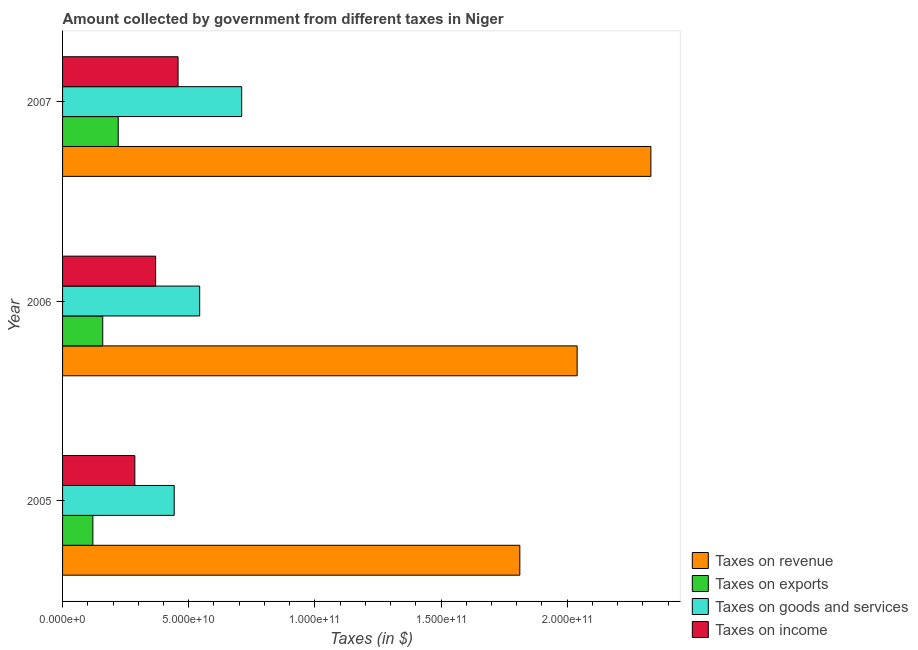How many different coloured bars are there?
Your answer should be very brief. 4. How many bars are there on the 3rd tick from the top?
Give a very brief answer. 4. What is the label of the 2nd group of bars from the top?
Provide a succinct answer. 2006. In how many cases, is the number of bars for a given year not equal to the number of legend labels?
Offer a very short reply. 0. What is the amount collected as tax on exports in 2007?
Your answer should be very brief. 2.21e+1. Across all years, what is the maximum amount collected as tax on income?
Provide a short and direct response. 4.58e+1. Across all years, what is the minimum amount collected as tax on income?
Provide a succinct answer. 2.86e+1. In which year was the amount collected as tax on income maximum?
Offer a terse response. 2007. What is the total amount collected as tax on revenue in the graph?
Keep it short and to the point. 6.18e+11. What is the difference between the amount collected as tax on revenue in 2005 and that in 2007?
Your answer should be compact. -5.19e+1. What is the difference between the amount collected as tax on exports in 2006 and the amount collected as tax on income in 2007?
Offer a very short reply. -2.99e+1. What is the average amount collected as tax on income per year?
Your answer should be very brief. 3.71e+1. In the year 2005, what is the difference between the amount collected as tax on goods and amount collected as tax on exports?
Offer a very short reply. 3.22e+1. What is the ratio of the amount collected as tax on exports in 2005 to that in 2006?
Offer a very short reply. 0.75. What is the difference between the highest and the second highest amount collected as tax on revenue?
Offer a terse response. 2.92e+1. What is the difference between the highest and the lowest amount collected as tax on exports?
Provide a short and direct response. 1.01e+1. In how many years, is the amount collected as tax on income greater than the average amount collected as tax on income taken over all years?
Your answer should be compact. 1. Is the sum of the amount collected as tax on revenue in 2005 and 2007 greater than the maximum amount collected as tax on income across all years?
Offer a very short reply. Yes. What does the 3rd bar from the top in 2006 represents?
Ensure brevity in your answer.  Taxes on exports. What does the 1st bar from the bottom in 2007 represents?
Ensure brevity in your answer.  Taxes on revenue. Is it the case that in every year, the sum of the amount collected as tax on revenue and amount collected as tax on exports is greater than the amount collected as tax on goods?
Offer a terse response. Yes. How many bars are there?
Your answer should be very brief. 12. Are all the bars in the graph horizontal?
Provide a succinct answer. Yes. How many years are there in the graph?
Provide a short and direct response. 3. What is the difference between two consecutive major ticks on the X-axis?
Provide a succinct answer. 5.00e+1. Are the values on the major ticks of X-axis written in scientific E-notation?
Offer a very short reply. Yes. Where does the legend appear in the graph?
Give a very brief answer. Bottom right. What is the title of the graph?
Your response must be concise. Amount collected by government from different taxes in Niger. Does "Rule based governance" appear as one of the legend labels in the graph?
Provide a short and direct response. No. What is the label or title of the X-axis?
Your response must be concise. Taxes (in $). What is the label or title of the Y-axis?
Your answer should be compact. Year. What is the Taxes (in $) in Taxes on revenue in 2005?
Give a very brief answer. 1.81e+11. What is the Taxes (in $) in Taxes on exports in 2005?
Provide a succinct answer. 1.20e+1. What is the Taxes (in $) of Taxes on goods and services in 2005?
Your answer should be very brief. 4.43e+1. What is the Taxes (in $) of Taxes on income in 2005?
Keep it short and to the point. 2.86e+1. What is the Taxes (in $) in Taxes on revenue in 2006?
Provide a short and direct response. 2.04e+11. What is the Taxes (in $) in Taxes on exports in 2006?
Your answer should be compact. 1.59e+1. What is the Taxes (in $) in Taxes on goods and services in 2006?
Your answer should be compact. 5.43e+1. What is the Taxes (in $) in Taxes on income in 2006?
Keep it short and to the point. 3.69e+1. What is the Taxes (in $) of Taxes on revenue in 2007?
Your answer should be very brief. 2.33e+11. What is the Taxes (in $) in Taxes on exports in 2007?
Offer a terse response. 2.21e+1. What is the Taxes (in $) of Taxes on goods and services in 2007?
Keep it short and to the point. 7.10e+1. What is the Taxes (in $) of Taxes on income in 2007?
Your answer should be very brief. 4.58e+1. Across all years, what is the maximum Taxes (in $) in Taxes on revenue?
Give a very brief answer. 2.33e+11. Across all years, what is the maximum Taxes (in $) in Taxes on exports?
Your response must be concise. 2.21e+1. Across all years, what is the maximum Taxes (in $) in Taxes on goods and services?
Offer a very short reply. 7.10e+1. Across all years, what is the maximum Taxes (in $) of Taxes on income?
Offer a terse response. 4.58e+1. Across all years, what is the minimum Taxes (in $) of Taxes on revenue?
Offer a very short reply. 1.81e+11. Across all years, what is the minimum Taxes (in $) in Taxes on exports?
Give a very brief answer. 1.20e+1. Across all years, what is the minimum Taxes (in $) of Taxes on goods and services?
Make the answer very short. 4.43e+1. Across all years, what is the minimum Taxes (in $) of Taxes on income?
Make the answer very short. 2.86e+1. What is the total Taxes (in $) in Taxes on revenue in the graph?
Provide a succinct answer. 6.18e+11. What is the total Taxes (in $) of Taxes on exports in the graph?
Make the answer very short. 5.00e+1. What is the total Taxes (in $) in Taxes on goods and services in the graph?
Your response must be concise. 1.70e+11. What is the total Taxes (in $) in Taxes on income in the graph?
Provide a short and direct response. 1.11e+11. What is the difference between the Taxes (in $) in Taxes on revenue in 2005 and that in 2006?
Your answer should be very brief. -2.27e+1. What is the difference between the Taxes (in $) of Taxes on exports in 2005 and that in 2006?
Offer a very short reply. -3.91e+09. What is the difference between the Taxes (in $) in Taxes on goods and services in 2005 and that in 2006?
Provide a succinct answer. -1.01e+1. What is the difference between the Taxes (in $) in Taxes on income in 2005 and that in 2006?
Provide a succinct answer. -8.25e+09. What is the difference between the Taxes (in $) of Taxes on revenue in 2005 and that in 2007?
Your response must be concise. -5.19e+1. What is the difference between the Taxes (in $) in Taxes on exports in 2005 and that in 2007?
Keep it short and to the point. -1.01e+1. What is the difference between the Taxes (in $) of Taxes on goods and services in 2005 and that in 2007?
Provide a short and direct response. -2.67e+1. What is the difference between the Taxes (in $) in Taxes on income in 2005 and that in 2007?
Provide a short and direct response. -1.71e+1. What is the difference between the Taxes (in $) in Taxes on revenue in 2006 and that in 2007?
Your response must be concise. -2.92e+1. What is the difference between the Taxes (in $) in Taxes on exports in 2006 and that in 2007?
Your answer should be very brief. -6.14e+09. What is the difference between the Taxes (in $) in Taxes on goods and services in 2006 and that in 2007?
Your answer should be compact. -1.66e+1. What is the difference between the Taxes (in $) in Taxes on income in 2006 and that in 2007?
Provide a short and direct response. -8.88e+09. What is the difference between the Taxes (in $) in Taxes on revenue in 2005 and the Taxes (in $) in Taxes on exports in 2006?
Your answer should be compact. 1.65e+11. What is the difference between the Taxes (in $) in Taxes on revenue in 2005 and the Taxes (in $) in Taxes on goods and services in 2006?
Give a very brief answer. 1.27e+11. What is the difference between the Taxes (in $) in Taxes on revenue in 2005 and the Taxes (in $) in Taxes on income in 2006?
Your answer should be very brief. 1.44e+11. What is the difference between the Taxes (in $) in Taxes on exports in 2005 and the Taxes (in $) in Taxes on goods and services in 2006?
Ensure brevity in your answer.  -4.23e+1. What is the difference between the Taxes (in $) of Taxes on exports in 2005 and the Taxes (in $) of Taxes on income in 2006?
Make the answer very short. -2.49e+1. What is the difference between the Taxes (in $) of Taxes on goods and services in 2005 and the Taxes (in $) of Taxes on income in 2006?
Make the answer very short. 7.36e+09. What is the difference between the Taxes (in $) of Taxes on revenue in 2005 and the Taxes (in $) of Taxes on exports in 2007?
Your response must be concise. 1.59e+11. What is the difference between the Taxes (in $) in Taxes on revenue in 2005 and the Taxes (in $) in Taxes on goods and services in 2007?
Ensure brevity in your answer.  1.10e+11. What is the difference between the Taxes (in $) of Taxes on revenue in 2005 and the Taxes (in $) of Taxes on income in 2007?
Ensure brevity in your answer.  1.35e+11. What is the difference between the Taxes (in $) of Taxes on exports in 2005 and the Taxes (in $) of Taxes on goods and services in 2007?
Ensure brevity in your answer.  -5.90e+1. What is the difference between the Taxes (in $) in Taxes on exports in 2005 and the Taxes (in $) in Taxes on income in 2007?
Provide a short and direct response. -3.38e+1. What is the difference between the Taxes (in $) in Taxes on goods and services in 2005 and the Taxes (in $) in Taxes on income in 2007?
Keep it short and to the point. -1.53e+09. What is the difference between the Taxes (in $) in Taxes on revenue in 2006 and the Taxes (in $) in Taxes on exports in 2007?
Keep it short and to the point. 1.82e+11. What is the difference between the Taxes (in $) in Taxes on revenue in 2006 and the Taxes (in $) in Taxes on goods and services in 2007?
Ensure brevity in your answer.  1.33e+11. What is the difference between the Taxes (in $) of Taxes on revenue in 2006 and the Taxes (in $) of Taxes on income in 2007?
Offer a terse response. 1.58e+11. What is the difference between the Taxes (in $) in Taxes on exports in 2006 and the Taxes (in $) in Taxes on goods and services in 2007?
Your answer should be compact. -5.51e+1. What is the difference between the Taxes (in $) in Taxes on exports in 2006 and the Taxes (in $) in Taxes on income in 2007?
Offer a very short reply. -2.99e+1. What is the difference between the Taxes (in $) in Taxes on goods and services in 2006 and the Taxes (in $) in Taxes on income in 2007?
Provide a succinct answer. 8.57e+09. What is the average Taxes (in $) of Taxes on revenue per year?
Give a very brief answer. 2.06e+11. What is the average Taxes (in $) in Taxes on exports per year?
Provide a succinct answer. 1.67e+1. What is the average Taxes (in $) in Taxes on goods and services per year?
Offer a terse response. 5.65e+1. What is the average Taxes (in $) in Taxes on income per year?
Provide a succinct answer. 3.71e+1. In the year 2005, what is the difference between the Taxes (in $) of Taxes on revenue and Taxes (in $) of Taxes on exports?
Offer a terse response. 1.69e+11. In the year 2005, what is the difference between the Taxes (in $) of Taxes on revenue and Taxes (in $) of Taxes on goods and services?
Your response must be concise. 1.37e+11. In the year 2005, what is the difference between the Taxes (in $) of Taxes on revenue and Taxes (in $) of Taxes on income?
Your response must be concise. 1.53e+11. In the year 2005, what is the difference between the Taxes (in $) of Taxes on exports and Taxes (in $) of Taxes on goods and services?
Your response must be concise. -3.22e+1. In the year 2005, what is the difference between the Taxes (in $) in Taxes on exports and Taxes (in $) in Taxes on income?
Provide a short and direct response. -1.66e+1. In the year 2005, what is the difference between the Taxes (in $) in Taxes on goods and services and Taxes (in $) in Taxes on income?
Make the answer very short. 1.56e+1. In the year 2006, what is the difference between the Taxes (in $) of Taxes on revenue and Taxes (in $) of Taxes on exports?
Make the answer very short. 1.88e+11. In the year 2006, what is the difference between the Taxes (in $) of Taxes on revenue and Taxes (in $) of Taxes on goods and services?
Provide a short and direct response. 1.50e+11. In the year 2006, what is the difference between the Taxes (in $) in Taxes on revenue and Taxes (in $) in Taxes on income?
Offer a very short reply. 1.67e+11. In the year 2006, what is the difference between the Taxes (in $) of Taxes on exports and Taxes (in $) of Taxes on goods and services?
Offer a very short reply. -3.84e+1. In the year 2006, what is the difference between the Taxes (in $) in Taxes on exports and Taxes (in $) in Taxes on income?
Give a very brief answer. -2.10e+1. In the year 2006, what is the difference between the Taxes (in $) of Taxes on goods and services and Taxes (in $) of Taxes on income?
Make the answer very short. 1.75e+1. In the year 2007, what is the difference between the Taxes (in $) of Taxes on revenue and Taxes (in $) of Taxes on exports?
Your answer should be compact. 2.11e+11. In the year 2007, what is the difference between the Taxes (in $) of Taxes on revenue and Taxes (in $) of Taxes on goods and services?
Your response must be concise. 1.62e+11. In the year 2007, what is the difference between the Taxes (in $) in Taxes on revenue and Taxes (in $) in Taxes on income?
Provide a short and direct response. 1.87e+11. In the year 2007, what is the difference between the Taxes (in $) of Taxes on exports and Taxes (in $) of Taxes on goods and services?
Make the answer very short. -4.89e+1. In the year 2007, what is the difference between the Taxes (in $) of Taxes on exports and Taxes (in $) of Taxes on income?
Give a very brief answer. -2.37e+1. In the year 2007, what is the difference between the Taxes (in $) in Taxes on goods and services and Taxes (in $) in Taxes on income?
Make the answer very short. 2.52e+1. What is the ratio of the Taxes (in $) of Taxes on revenue in 2005 to that in 2006?
Provide a succinct answer. 0.89. What is the ratio of the Taxes (in $) of Taxes on exports in 2005 to that in 2006?
Your response must be concise. 0.75. What is the ratio of the Taxes (in $) of Taxes on goods and services in 2005 to that in 2006?
Your response must be concise. 0.81. What is the ratio of the Taxes (in $) in Taxes on income in 2005 to that in 2006?
Keep it short and to the point. 0.78. What is the ratio of the Taxes (in $) in Taxes on revenue in 2005 to that in 2007?
Offer a very short reply. 0.78. What is the ratio of the Taxes (in $) of Taxes on exports in 2005 to that in 2007?
Keep it short and to the point. 0.54. What is the ratio of the Taxes (in $) in Taxes on goods and services in 2005 to that in 2007?
Provide a succinct answer. 0.62. What is the ratio of the Taxes (in $) of Taxes on income in 2005 to that in 2007?
Your answer should be compact. 0.63. What is the ratio of the Taxes (in $) in Taxes on revenue in 2006 to that in 2007?
Provide a short and direct response. 0.87. What is the ratio of the Taxes (in $) in Taxes on exports in 2006 to that in 2007?
Your answer should be very brief. 0.72. What is the ratio of the Taxes (in $) in Taxes on goods and services in 2006 to that in 2007?
Your response must be concise. 0.77. What is the ratio of the Taxes (in $) in Taxes on income in 2006 to that in 2007?
Keep it short and to the point. 0.81. What is the difference between the highest and the second highest Taxes (in $) of Taxes on revenue?
Provide a short and direct response. 2.92e+1. What is the difference between the highest and the second highest Taxes (in $) in Taxes on exports?
Offer a terse response. 6.14e+09. What is the difference between the highest and the second highest Taxes (in $) in Taxes on goods and services?
Offer a terse response. 1.66e+1. What is the difference between the highest and the second highest Taxes (in $) of Taxes on income?
Provide a succinct answer. 8.88e+09. What is the difference between the highest and the lowest Taxes (in $) in Taxes on revenue?
Provide a succinct answer. 5.19e+1. What is the difference between the highest and the lowest Taxes (in $) in Taxes on exports?
Provide a succinct answer. 1.01e+1. What is the difference between the highest and the lowest Taxes (in $) of Taxes on goods and services?
Make the answer very short. 2.67e+1. What is the difference between the highest and the lowest Taxes (in $) in Taxes on income?
Offer a terse response. 1.71e+1. 